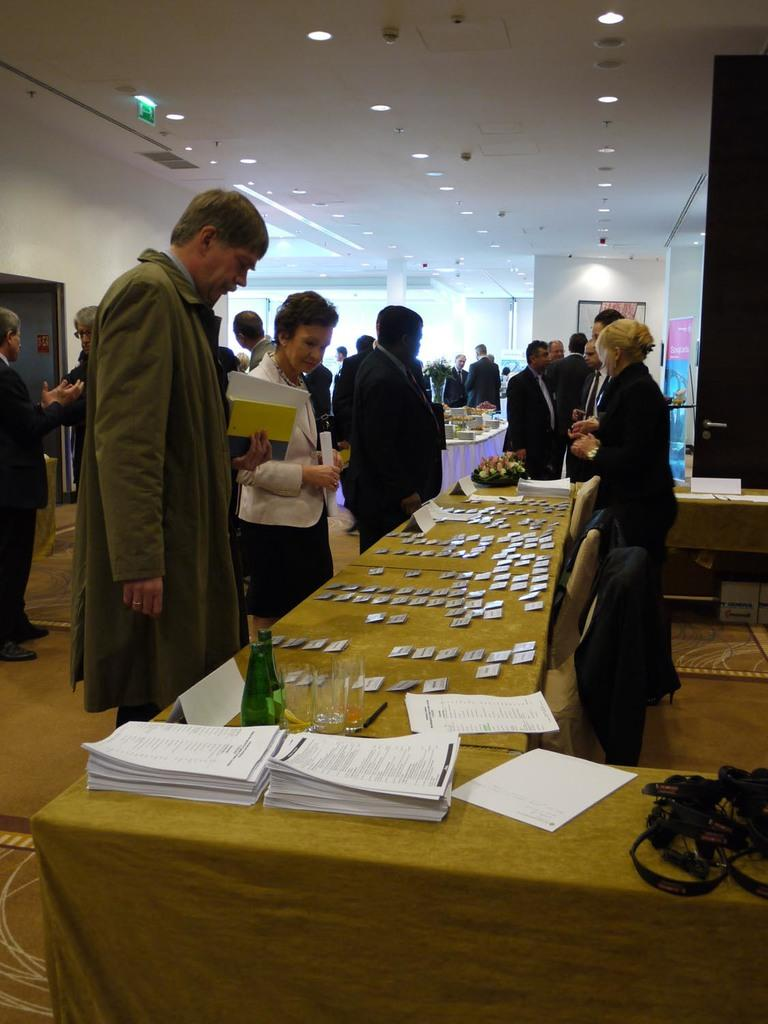What can be seen in the image in terms of people? There are people standing in the image. What is the color of the wall visible in the image? There is a white color wall in the image. What piece of furniture is present in the image? There is a table in the image. What objects are on the table? There is a bottle and papers on the table. What type of cabbage is being used as bait on the table in the image? There is no cabbage or bait present on the table in the image. What type of polish is being applied to the people in the image? There is no polish or indication of any such activity in the image. 